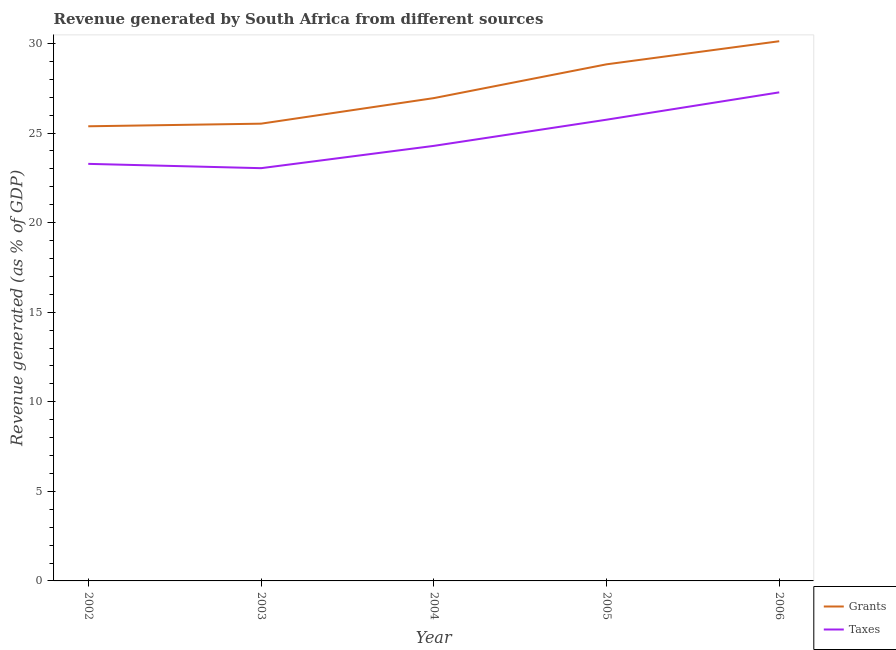How many different coloured lines are there?
Give a very brief answer. 2. Does the line corresponding to revenue generated by grants intersect with the line corresponding to revenue generated by taxes?
Offer a very short reply. No. Is the number of lines equal to the number of legend labels?
Ensure brevity in your answer.  Yes. What is the revenue generated by grants in 2004?
Ensure brevity in your answer.  26.95. Across all years, what is the maximum revenue generated by grants?
Offer a very short reply. 30.12. Across all years, what is the minimum revenue generated by taxes?
Provide a succinct answer. 23.04. In which year was the revenue generated by taxes maximum?
Give a very brief answer. 2006. What is the total revenue generated by grants in the graph?
Keep it short and to the point. 136.8. What is the difference between the revenue generated by grants in 2003 and that in 2006?
Offer a very short reply. -4.6. What is the difference between the revenue generated by grants in 2002 and the revenue generated by taxes in 2006?
Your response must be concise. -1.89. What is the average revenue generated by grants per year?
Offer a very short reply. 27.36. In the year 2006, what is the difference between the revenue generated by taxes and revenue generated by grants?
Provide a short and direct response. -2.85. In how many years, is the revenue generated by grants greater than 16 %?
Make the answer very short. 5. What is the ratio of the revenue generated by taxes in 2003 to that in 2005?
Offer a very short reply. 0.89. Is the revenue generated by grants in 2002 less than that in 2006?
Your answer should be compact. Yes. What is the difference between the highest and the second highest revenue generated by grants?
Your answer should be very brief. 1.29. What is the difference between the highest and the lowest revenue generated by taxes?
Your response must be concise. 4.23. In how many years, is the revenue generated by grants greater than the average revenue generated by grants taken over all years?
Provide a succinct answer. 2. Is the revenue generated by grants strictly greater than the revenue generated by taxes over the years?
Provide a succinct answer. Yes. Is the revenue generated by taxes strictly less than the revenue generated by grants over the years?
Your answer should be very brief. Yes. How many lines are there?
Your response must be concise. 2. How many years are there in the graph?
Keep it short and to the point. 5. What is the difference between two consecutive major ticks on the Y-axis?
Ensure brevity in your answer.  5. Are the values on the major ticks of Y-axis written in scientific E-notation?
Your response must be concise. No. What is the title of the graph?
Offer a terse response. Revenue generated by South Africa from different sources. Does "Electricity" appear as one of the legend labels in the graph?
Your response must be concise. No. What is the label or title of the X-axis?
Ensure brevity in your answer.  Year. What is the label or title of the Y-axis?
Your answer should be compact. Revenue generated (as % of GDP). What is the Revenue generated (as % of GDP) in Grants in 2002?
Offer a terse response. 25.38. What is the Revenue generated (as % of GDP) of Taxes in 2002?
Give a very brief answer. 23.28. What is the Revenue generated (as % of GDP) in Grants in 2003?
Your answer should be compact. 25.52. What is the Revenue generated (as % of GDP) in Taxes in 2003?
Your answer should be very brief. 23.04. What is the Revenue generated (as % of GDP) in Grants in 2004?
Ensure brevity in your answer.  26.95. What is the Revenue generated (as % of GDP) of Taxes in 2004?
Provide a short and direct response. 24.28. What is the Revenue generated (as % of GDP) in Grants in 2005?
Provide a succinct answer. 28.83. What is the Revenue generated (as % of GDP) in Taxes in 2005?
Keep it short and to the point. 25.74. What is the Revenue generated (as % of GDP) of Grants in 2006?
Ensure brevity in your answer.  30.12. What is the Revenue generated (as % of GDP) in Taxes in 2006?
Give a very brief answer. 27.27. Across all years, what is the maximum Revenue generated (as % of GDP) in Grants?
Give a very brief answer. 30.12. Across all years, what is the maximum Revenue generated (as % of GDP) in Taxes?
Keep it short and to the point. 27.27. Across all years, what is the minimum Revenue generated (as % of GDP) of Grants?
Your response must be concise. 25.38. Across all years, what is the minimum Revenue generated (as % of GDP) in Taxes?
Offer a very short reply. 23.04. What is the total Revenue generated (as % of GDP) of Grants in the graph?
Your answer should be very brief. 136.8. What is the total Revenue generated (as % of GDP) of Taxes in the graph?
Your response must be concise. 123.61. What is the difference between the Revenue generated (as % of GDP) of Grants in 2002 and that in 2003?
Keep it short and to the point. -0.15. What is the difference between the Revenue generated (as % of GDP) of Taxes in 2002 and that in 2003?
Ensure brevity in your answer.  0.24. What is the difference between the Revenue generated (as % of GDP) in Grants in 2002 and that in 2004?
Provide a short and direct response. -1.57. What is the difference between the Revenue generated (as % of GDP) of Taxes in 2002 and that in 2004?
Offer a very short reply. -1. What is the difference between the Revenue generated (as % of GDP) in Grants in 2002 and that in 2005?
Your answer should be very brief. -3.46. What is the difference between the Revenue generated (as % of GDP) of Taxes in 2002 and that in 2005?
Keep it short and to the point. -2.46. What is the difference between the Revenue generated (as % of GDP) in Grants in 2002 and that in 2006?
Ensure brevity in your answer.  -4.75. What is the difference between the Revenue generated (as % of GDP) of Taxes in 2002 and that in 2006?
Provide a succinct answer. -3.99. What is the difference between the Revenue generated (as % of GDP) in Grants in 2003 and that in 2004?
Keep it short and to the point. -1.43. What is the difference between the Revenue generated (as % of GDP) in Taxes in 2003 and that in 2004?
Keep it short and to the point. -1.24. What is the difference between the Revenue generated (as % of GDP) in Grants in 2003 and that in 2005?
Your answer should be compact. -3.31. What is the difference between the Revenue generated (as % of GDP) of Taxes in 2003 and that in 2005?
Ensure brevity in your answer.  -2.71. What is the difference between the Revenue generated (as % of GDP) of Grants in 2003 and that in 2006?
Ensure brevity in your answer.  -4.6. What is the difference between the Revenue generated (as % of GDP) of Taxes in 2003 and that in 2006?
Offer a very short reply. -4.23. What is the difference between the Revenue generated (as % of GDP) in Grants in 2004 and that in 2005?
Give a very brief answer. -1.89. What is the difference between the Revenue generated (as % of GDP) of Taxes in 2004 and that in 2005?
Your answer should be very brief. -1.46. What is the difference between the Revenue generated (as % of GDP) in Grants in 2004 and that in 2006?
Provide a short and direct response. -3.18. What is the difference between the Revenue generated (as % of GDP) of Taxes in 2004 and that in 2006?
Provide a succinct answer. -2.99. What is the difference between the Revenue generated (as % of GDP) of Grants in 2005 and that in 2006?
Offer a very short reply. -1.29. What is the difference between the Revenue generated (as % of GDP) of Taxes in 2005 and that in 2006?
Your response must be concise. -1.53. What is the difference between the Revenue generated (as % of GDP) of Grants in 2002 and the Revenue generated (as % of GDP) of Taxes in 2003?
Ensure brevity in your answer.  2.34. What is the difference between the Revenue generated (as % of GDP) of Grants in 2002 and the Revenue generated (as % of GDP) of Taxes in 2004?
Your response must be concise. 1.09. What is the difference between the Revenue generated (as % of GDP) of Grants in 2002 and the Revenue generated (as % of GDP) of Taxes in 2005?
Ensure brevity in your answer.  -0.37. What is the difference between the Revenue generated (as % of GDP) in Grants in 2002 and the Revenue generated (as % of GDP) in Taxes in 2006?
Provide a short and direct response. -1.89. What is the difference between the Revenue generated (as % of GDP) in Grants in 2003 and the Revenue generated (as % of GDP) in Taxes in 2004?
Your response must be concise. 1.24. What is the difference between the Revenue generated (as % of GDP) in Grants in 2003 and the Revenue generated (as % of GDP) in Taxes in 2005?
Keep it short and to the point. -0.22. What is the difference between the Revenue generated (as % of GDP) of Grants in 2003 and the Revenue generated (as % of GDP) of Taxes in 2006?
Offer a very short reply. -1.75. What is the difference between the Revenue generated (as % of GDP) of Grants in 2004 and the Revenue generated (as % of GDP) of Taxes in 2005?
Offer a very short reply. 1.2. What is the difference between the Revenue generated (as % of GDP) of Grants in 2004 and the Revenue generated (as % of GDP) of Taxes in 2006?
Your response must be concise. -0.32. What is the difference between the Revenue generated (as % of GDP) in Grants in 2005 and the Revenue generated (as % of GDP) in Taxes in 2006?
Provide a short and direct response. 1.56. What is the average Revenue generated (as % of GDP) in Grants per year?
Make the answer very short. 27.36. What is the average Revenue generated (as % of GDP) in Taxes per year?
Provide a succinct answer. 24.72. In the year 2002, what is the difference between the Revenue generated (as % of GDP) of Grants and Revenue generated (as % of GDP) of Taxes?
Offer a terse response. 2.1. In the year 2003, what is the difference between the Revenue generated (as % of GDP) in Grants and Revenue generated (as % of GDP) in Taxes?
Provide a short and direct response. 2.48. In the year 2004, what is the difference between the Revenue generated (as % of GDP) of Grants and Revenue generated (as % of GDP) of Taxes?
Keep it short and to the point. 2.67. In the year 2005, what is the difference between the Revenue generated (as % of GDP) in Grants and Revenue generated (as % of GDP) in Taxes?
Offer a terse response. 3.09. In the year 2006, what is the difference between the Revenue generated (as % of GDP) in Grants and Revenue generated (as % of GDP) in Taxes?
Provide a succinct answer. 2.85. What is the ratio of the Revenue generated (as % of GDP) in Grants in 2002 to that in 2003?
Offer a terse response. 0.99. What is the ratio of the Revenue generated (as % of GDP) in Taxes in 2002 to that in 2003?
Ensure brevity in your answer.  1.01. What is the ratio of the Revenue generated (as % of GDP) of Grants in 2002 to that in 2004?
Provide a short and direct response. 0.94. What is the ratio of the Revenue generated (as % of GDP) of Taxes in 2002 to that in 2004?
Your answer should be very brief. 0.96. What is the ratio of the Revenue generated (as % of GDP) of Grants in 2002 to that in 2005?
Keep it short and to the point. 0.88. What is the ratio of the Revenue generated (as % of GDP) of Taxes in 2002 to that in 2005?
Make the answer very short. 0.9. What is the ratio of the Revenue generated (as % of GDP) in Grants in 2002 to that in 2006?
Your answer should be compact. 0.84. What is the ratio of the Revenue generated (as % of GDP) of Taxes in 2002 to that in 2006?
Offer a very short reply. 0.85. What is the ratio of the Revenue generated (as % of GDP) of Grants in 2003 to that in 2004?
Make the answer very short. 0.95. What is the ratio of the Revenue generated (as % of GDP) in Taxes in 2003 to that in 2004?
Offer a very short reply. 0.95. What is the ratio of the Revenue generated (as % of GDP) of Grants in 2003 to that in 2005?
Keep it short and to the point. 0.89. What is the ratio of the Revenue generated (as % of GDP) of Taxes in 2003 to that in 2005?
Provide a succinct answer. 0.89. What is the ratio of the Revenue generated (as % of GDP) in Grants in 2003 to that in 2006?
Ensure brevity in your answer.  0.85. What is the ratio of the Revenue generated (as % of GDP) in Taxes in 2003 to that in 2006?
Provide a short and direct response. 0.84. What is the ratio of the Revenue generated (as % of GDP) of Grants in 2004 to that in 2005?
Your answer should be very brief. 0.93. What is the ratio of the Revenue generated (as % of GDP) of Taxes in 2004 to that in 2005?
Your answer should be very brief. 0.94. What is the ratio of the Revenue generated (as % of GDP) in Grants in 2004 to that in 2006?
Provide a succinct answer. 0.89. What is the ratio of the Revenue generated (as % of GDP) of Taxes in 2004 to that in 2006?
Your answer should be compact. 0.89. What is the ratio of the Revenue generated (as % of GDP) of Grants in 2005 to that in 2006?
Ensure brevity in your answer.  0.96. What is the ratio of the Revenue generated (as % of GDP) of Taxes in 2005 to that in 2006?
Offer a terse response. 0.94. What is the difference between the highest and the second highest Revenue generated (as % of GDP) in Grants?
Your answer should be very brief. 1.29. What is the difference between the highest and the second highest Revenue generated (as % of GDP) in Taxes?
Provide a short and direct response. 1.53. What is the difference between the highest and the lowest Revenue generated (as % of GDP) of Grants?
Keep it short and to the point. 4.75. What is the difference between the highest and the lowest Revenue generated (as % of GDP) in Taxes?
Ensure brevity in your answer.  4.23. 